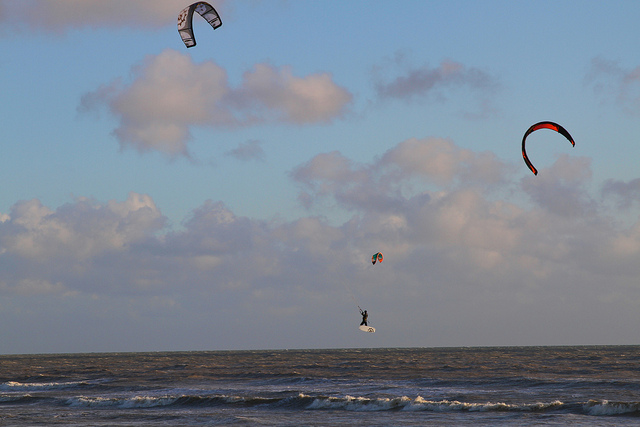How many kites can you count in the image? Upon closer inspection, the image reveals a total of three kites adorning the sky, each with distinct designs and auras, possibly reflecting the individual personalities of the kite surfers controlling them from below. 